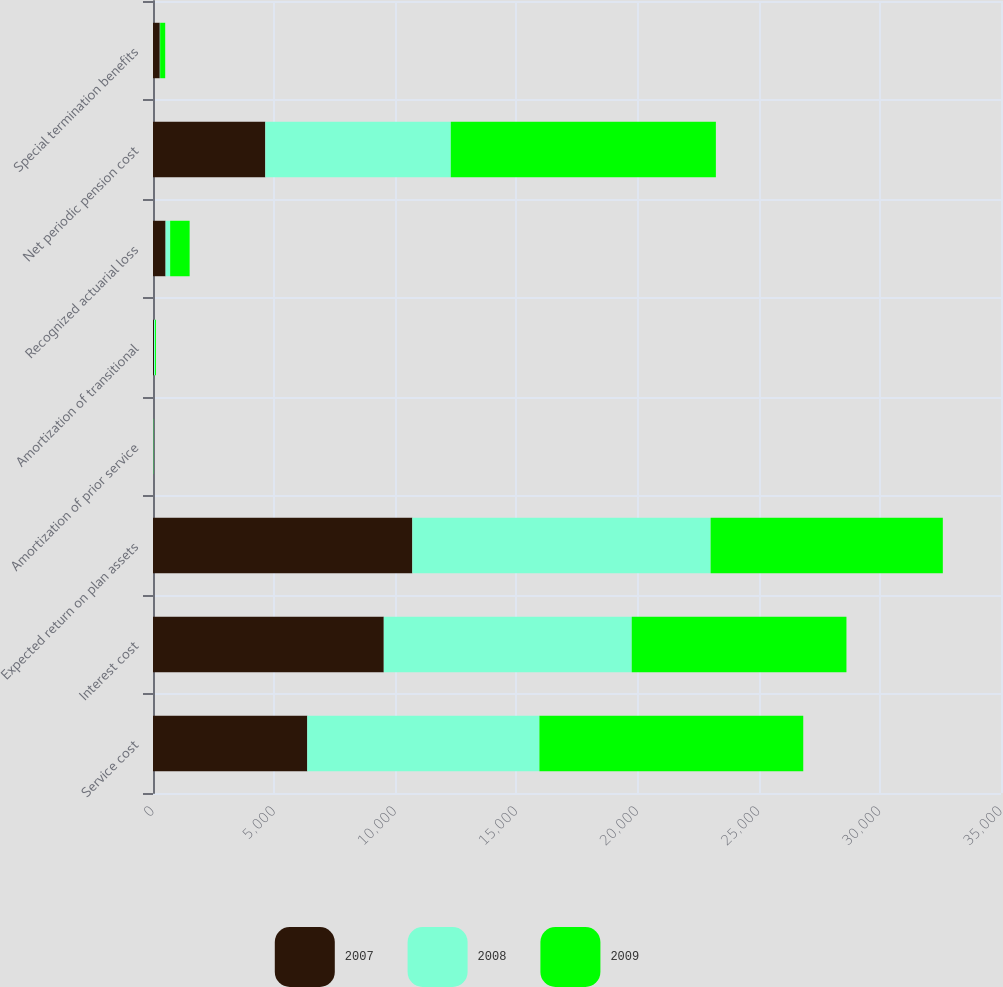Convert chart to OTSL. <chart><loc_0><loc_0><loc_500><loc_500><stacked_bar_chart><ecel><fcel>Service cost<fcel>Interest cost<fcel>Expected return on plan assets<fcel>Amortization of prior service<fcel>Amortization of transitional<fcel>Recognized actuarial loss<fcel>Net periodic pension cost<fcel>Special termination benefits<nl><fcel>2007<fcel>6368<fcel>9525<fcel>10703<fcel>5<fcel>40<fcel>519<fcel>4636<fcel>281<nl><fcel>2008<fcel>9580<fcel>10234<fcel>12312<fcel>8<fcel>44<fcel>189<fcel>7655<fcel>15<nl><fcel>2009<fcel>10890<fcel>8862<fcel>9584<fcel>8<fcel>39<fcel>804<fcel>10941<fcel>207<nl></chart> 